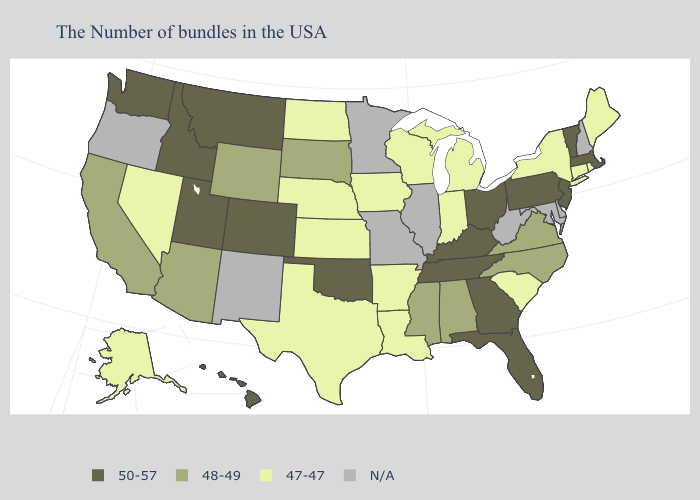Among the states that border Florida , which have the highest value?
Concise answer only. Georgia. What is the value of Alaska?
Short answer required. 47-47. Among the states that border Virginia , which have the lowest value?
Concise answer only. North Carolina. Does Oklahoma have the lowest value in the South?
Give a very brief answer. No. Is the legend a continuous bar?
Answer briefly. No. Name the states that have a value in the range 48-49?
Short answer required. Virginia, North Carolina, Alabama, Mississippi, South Dakota, Wyoming, Arizona, California. What is the value of Arkansas?
Keep it brief. 47-47. Which states hav the highest value in the West?
Be succinct. Colorado, Utah, Montana, Idaho, Washington, Hawaii. What is the value of North Carolina?
Be succinct. 48-49. What is the highest value in the South ?
Give a very brief answer. 50-57. What is the value of Maine?
Keep it brief. 47-47. Which states have the lowest value in the West?
Give a very brief answer. Nevada, Alaska. How many symbols are there in the legend?
Answer briefly. 4. 